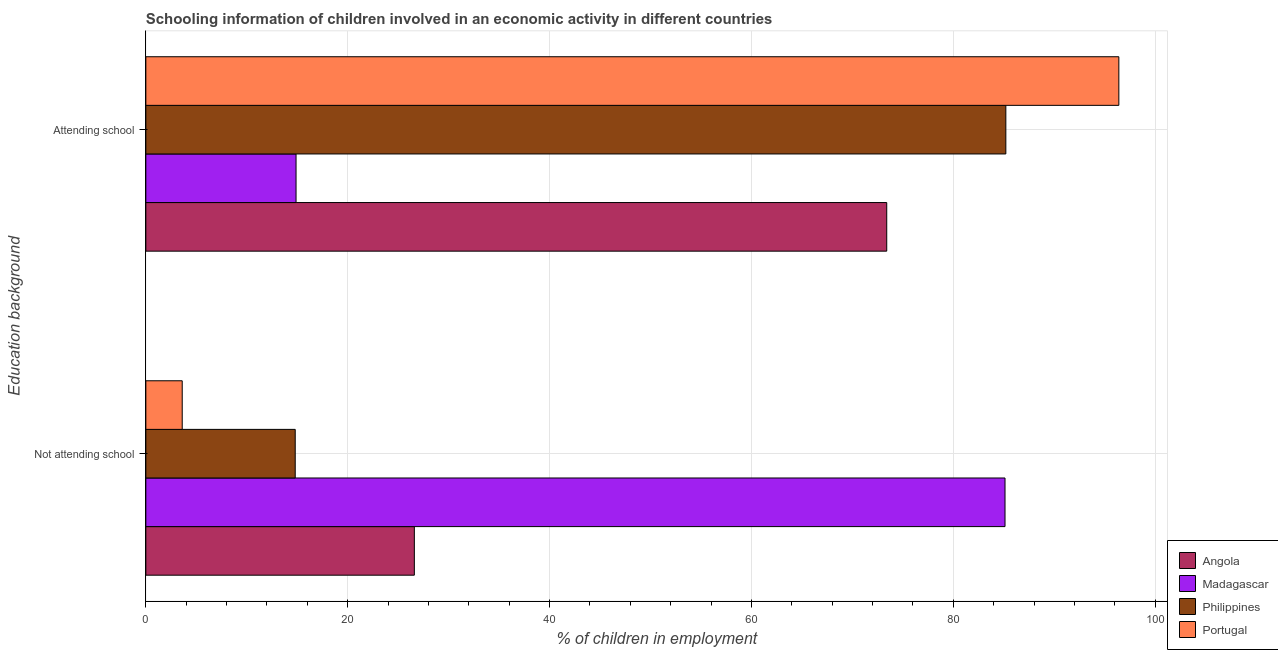How many different coloured bars are there?
Keep it short and to the point. 4. How many groups of bars are there?
Provide a short and direct response. 2. What is the label of the 1st group of bars from the top?
Your answer should be compact. Attending school. What is the percentage of employed children who are attending school in Philippines?
Ensure brevity in your answer.  85.2. Across all countries, what is the maximum percentage of employed children who are attending school?
Give a very brief answer. 96.4. Across all countries, what is the minimum percentage of employed children who are attending school?
Offer a very short reply. 14.88. In which country was the percentage of employed children who are attending school maximum?
Give a very brief answer. Portugal. In which country was the percentage of employed children who are not attending school minimum?
Make the answer very short. Portugal. What is the total percentage of employed children who are attending school in the graph?
Make the answer very short. 269.88. What is the difference between the percentage of employed children who are not attending school in Portugal and that in Madagascar?
Ensure brevity in your answer.  -81.51. What is the difference between the percentage of employed children who are attending school in Portugal and the percentage of employed children who are not attending school in Madagascar?
Provide a succinct answer. 11.28. What is the average percentage of employed children who are attending school per country?
Provide a succinct answer. 67.47. What is the difference between the percentage of employed children who are attending school and percentage of employed children who are not attending school in Angola?
Your answer should be compact. 46.8. In how many countries, is the percentage of employed children who are not attending school greater than 52 %?
Offer a terse response. 1. What is the ratio of the percentage of employed children who are attending school in Portugal to that in Madagascar?
Ensure brevity in your answer.  6.48. Is the percentage of employed children who are not attending school in Angola less than that in Philippines?
Offer a terse response. No. In how many countries, is the percentage of employed children who are not attending school greater than the average percentage of employed children who are not attending school taken over all countries?
Your answer should be very brief. 1. What does the 4th bar from the top in Attending school represents?
Give a very brief answer. Angola. What does the 1st bar from the bottom in Attending school represents?
Keep it short and to the point. Angola. How many bars are there?
Provide a short and direct response. 8. What is the difference between two consecutive major ticks on the X-axis?
Make the answer very short. 20. Are the values on the major ticks of X-axis written in scientific E-notation?
Your answer should be very brief. No. Does the graph contain any zero values?
Provide a short and direct response. No. Does the graph contain grids?
Offer a terse response. Yes. How many legend labels are there?
Ensure brevity in your answer.  4. How are the legend labels stacked?
Ensure brevity in your answer.  Vertical. What is the title of the graph?
Ensure brevity in your answer.  Schooling information of children involved in an economic activity in different countries. Does "Sweden" appear as one of the legend labels in the graph?
Offer a very short reply. No. What is the label or title of the X-axis?
Your response must be concise. % of children in employment. What is the label or title of the Y-axis?
Your answer should be very brief. Education background. What is the % of children in employment in Angola in Not attending school?
Offer a very short reply. 26.6. What is the % of children in employment of Madagascar in Not attending school?
Provide a short and direct response. 85.12. What is the % of children in employment of Philippines in Not attending school?
Make the answer very short. 14.8. What is the % of children in employment of Portugal in Not attending school?
Your response must be concise. 3.6. What is the % of children in employment of Angola in Attending school?
Your answer should be compact. 73.4. What is the % of children in employment in Madagascar in Attending school?
Ensure brevity in your answer.  14.88. What is the % of children in employment in Philippines in Attending school?
Your answer should be compact. 85.2. What is the % of children in employment of Portugal in Attending school?
Provide a succinct answer. 96.4. Across all Education background, what is the maximum % of children in employment of Angola?
Provide a short and direct response. 73.4. Across all Education background, what is the maximum % of children in employment in Madagascar?
Your answer should be compact. 85.12. Across all Education background, what is the maximum % of children in employment of Philippines?
Provide a succinct answer. 85.2. Across all Education background, what is the maximum % of children in employment of Portugal?
Your answer should be very brief. 96.4. Across all Education background, what is the minimum % of children in employment of Angola?
Offer a very short reply. 26.6. Across all Education background, what is the minimum % of children in employment in Madagascar?
Make the answer very short. 14.88. Across all Education background, what is the minimum % of children in employment in Philippines?
Offer a terse response. 14.8. Across all Education background, what is the minimum % of children in employment in Portugal?
Your response must be concise. 3.6. What is the total % of children in employment of Angola in the graph?
Keep it short and to the point. 100. What is the total % of children in employment of Madagascar in the graph?
Your answer should be very brief. 100. What is the total % of children in employment of Philippines in the graph?
Make the answer very short. 100. What is the difference between the % of children in employment in Angola in Not attending school and that in Attending school?
Provide a short and direct response. -46.8. What is the difference between the % of children in employment in Madagascar in Not attending school and that in Attending school?
Keep it short and to the point. 70.24. What is the difference between the % of children in employment of Philippines in Not attending school and that in Attending school?
Your response must be concise. -70.4. What is the difference between the % of children in employment of Portugal in Not attending school and that in Attending school?
Make the answer very short. -92.79. What is the difference between the % of children in employment in Angola in Not attending school and the % of children in employment in Madagascar in Attending school?
Give a very brief answer. 11.72. What is the difference between the % of children in employment in Angola in Not attending school and the % of children in employment in Philippines in Attending school?
Make the answer very short. -58.6. What is the difference between the % of children in employment in Angola in Not attending school and the % of children in employment in Portugal in Attending school?
Your answer should be compact. -69.8. What is the difference between the % of children in employment in Madagascar in Not attending school and the % of children in employment in Philippines in Attending school?
Your answer should be compact. -0.08. What is the difference between the % of children in employment in Madagascar in Not attending school and the % of children in employment in Portugal in Attending school?
Your response must be concise. -11.28. What is the difference between the % of children in employment of Philippines in Not attending school and the % of children in employment of Portugal in Attending school?
Your response must be concise. -81.6. What is the average % of children in employment in Madagascar per Education background?
Give a very brief answer. 50. What is the average % of children in employment of Philippines per Education background?
Your response must be concise. 50. What is the average % of children in employment of Portugal per Education background?
Ensure brevity in your answer.  50. What is the difference between the % of children in employment of Angola and % of children in employment of Madagascar in Not attending school?
Offer a terse response. -58.52. What is the difference between the % of children in employment of Angola and % of children in employment of Philippines in Not attending school?
Provide a succinct answer. 11.8. What is the difference between the % of children in employment of Angola and % of children in employment of Portugal in Not attending school?
Make the answer very short. 23. What is the difference between the % of children in employment of Madagascar and % of children in employment of Philippines in Not attending school?
Make the answer very short. 70.32. What is the difference between the % of children in employment in Madagascar and % of children in employment in Portugal in Not attending school?
Provide a succinct answer. 81.51. What is the difference between the % of children in employment of Philippines and % of children in employment of Portugal in Not attending school?
Your answer should be compact. 11.19. What is the difference between the % of children in employment in Angola and % of children in employment in Madagascar in Attending school?
Give a very brief answer. 58.52. What is the difference between the % of children in employment in Angola and % of children in employment in Philippines in Attending school?
Make the answer very short. -11.8. What is the difference between the % of children in employment of Angola and % of children in employment of Portugal in Attending school?
Ensure brevity in your answer.  -23. What is the difference between the % of children in employment of Madagascar and % of children in employment of Philippines in Attending school?
Your answer should be compact. -70.32. What is the difference between the % of children in employment in Madagascar and % of children in employment in Portugal in Attending school?
Provide a short and direct response. -81.51. What is the difference between the % of children in employment of Philippines and % of children in employment of Portugal in Attending school?
Your response must be concise. -11.19. What is the ratio of the % of children in employment in Angola in Not attending school to that in Attending school?
Provide a succinct answer. 0.36. What is the ratio of the % of children in employment of Madagascar in Not attending school to that in Attending school?
Provide a short and direct response. 5.72. What is the ratio of the % of children in employment of Philippines in Not attending school to that in Attending school?
Make the answer very short. 0.17. What is the ratio of the % of children in employment in Portugal in Not attending school to that in Attending school?
Ensure brevity in your answer.  0.04. What is the difference between the highest and the second highest % of children in employment in Angola?
Your response must be concise. 46.8. What is the difference between the highest and the second highest % of children in employment of Madagascar?
Ensure brevity in your answer.  70.24. What is the difference between the highest and the second highest % of children in employment of Philippines?
Your response must be concise. 70.4. What is the difference between the highest and the second highest % of children in employment in Portugal?
Your answer should be very brief. 92.79. What is the difference between the highest and the lowest % of children in employment of Angola?
Ensure brevity in your answer.  46.8. What is the difference between the highest and the lowest % of children in employment in Madagascar?
Your answer should be very brief. 70.24. What is the difference between the highest and the lowest % of children in employment of Philippines?
Provide a short and direct response. 70.4. What is the difference between the highest and the lowest % of children in employment of Portugal?
Provide a short and direct response. 92.79. 